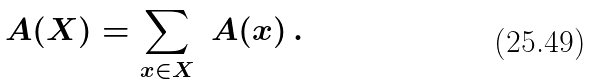Convert formula to latex. <formula><loc_0><loc_0><loc_500><loc_500>\ A ( X ) = \sum _ { x \in X } \ A ( x ) \, .</formula> 